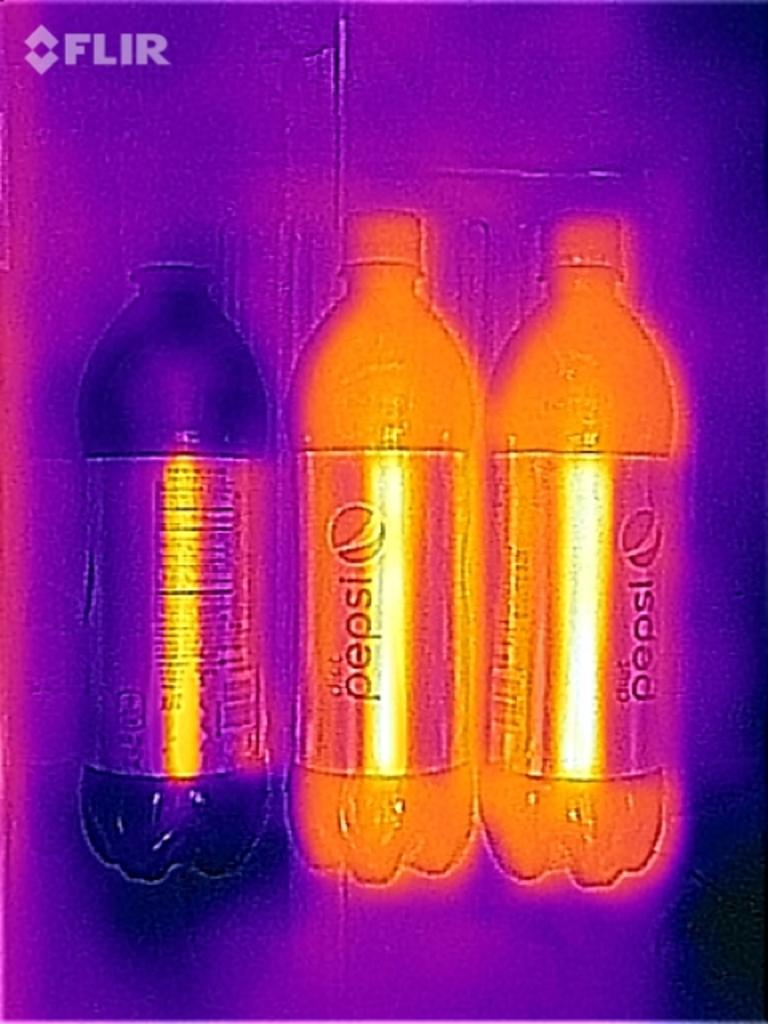<image>
Give a short and clear explanation of the subsequent image. Three Pepsi bottles are next to each other with unusual orange and pink lighting effects. 